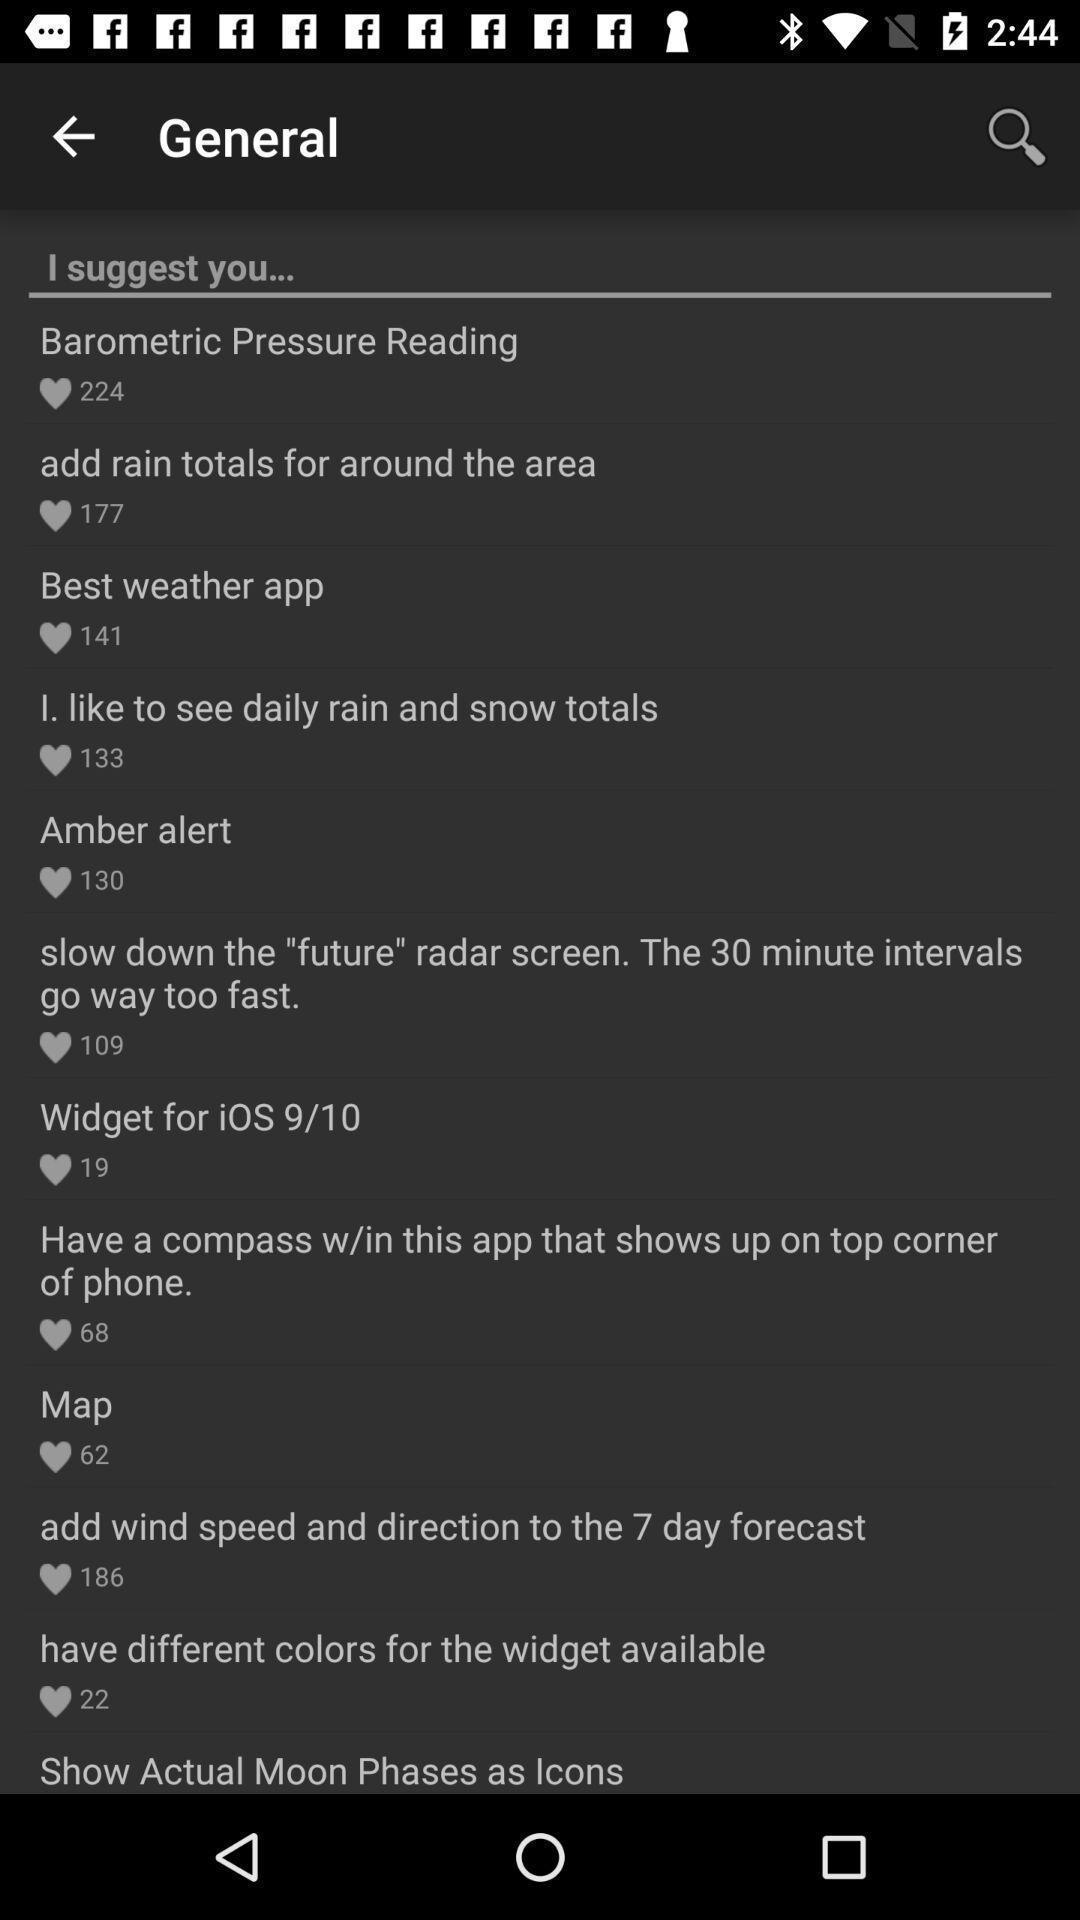Tell me about the visual elements in this screen capture. Page showing various suggestions. 